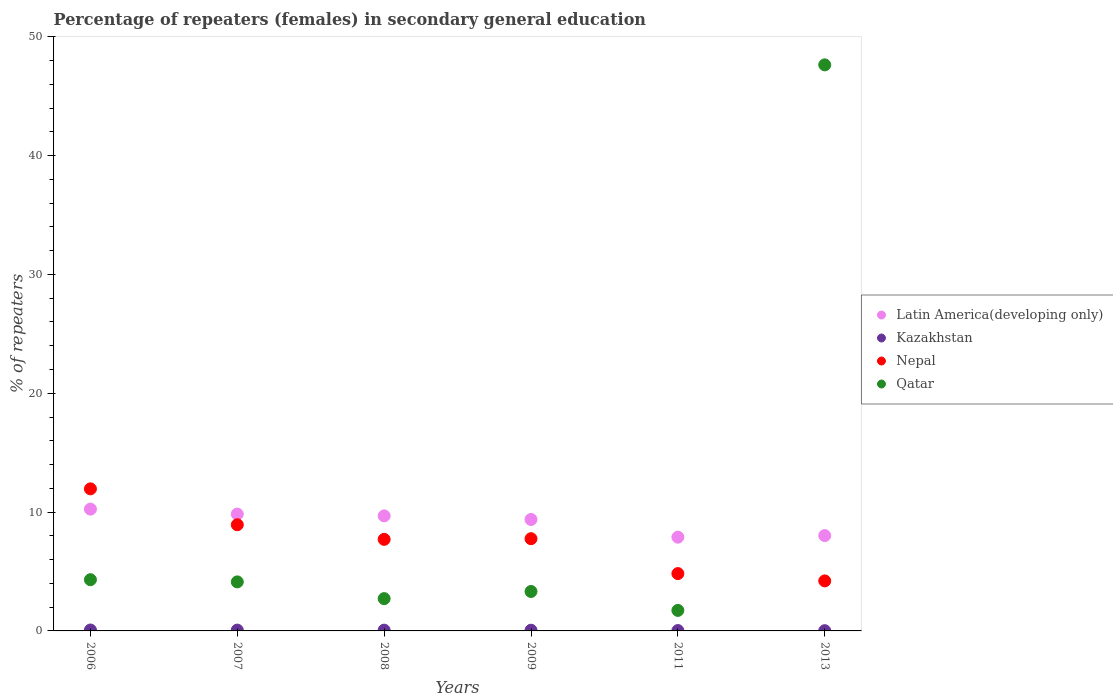Is the number of dotlines equal to the number of legend labels?
Make the answer very short. Yes. What is the percentage of female repeaters in Latin America(developing only) in 2013?
Provide a short and direct response. 8.02. Across all years, what is the maximum percentage of female repeaters in Qatar?
Ensure brevity in your answer.  47.64. Across all years, what is the minimum percentage of female repeaters in Latin America(developing only)?
Your answer should be compact. 7.89. In which year was the percentage of female repeaters in Qatar maximum?
Keep it short and to the point. 2013. What is the total percentage of female repeaters in Latin America(developing only) in the graph?
Make the answer very short. 55.06. What is the difference between the percentage of female repeaters in Latin America(developing only) in 2007 and that in 2013?
Offer a terse response. 1.81. What is the difference between the percentage of female repeaters in Qatar in 2006 and the percentage of female repeaters in Kazakhstan in 2009?
Provide a short and direct response. 4.25. What is the average percentage of female repeaters in Qatar per year?
Offer a very short reply. 10.64. In the year 2013, what is the difference between the percentage of female repeaters in Nepal and percentage of female repeaters in Qatar?
Offer a terse response. -43.43. In how many years, is the percentage of female repeaters in Nepal greater than 22 %?
Your answer should be very brief. 0. What is the ratio of the percentage of female repeaters in Latin America(developing only) in 2006 to that in 2007?
Your answer should be very brief. 1.04. Is the difference between the percentage of female repeaters in Nepal in 2008 and 2009 greater than the difference between the percentage of female repeaters in Qatar in 2008 and 2009?
Your answer should be compact. Yes. What is the difference between the highest and the second highest percentage of female repeaters in Qatar?
Give a very brief answer. 43.33. What is the difference between the highest and the lowest percentage of female repeaters in Latin America(developing only)?
Keep it short and to the point. 2.36. Is the sum of the percentage of female repeaters in Latin America(developing only) in 2008 and 2011 greater than the maximum percentage of female repeaters in Qatar across all years?
Keep it short and to the point. No. Does the percentage of female repeaters in Kazakhstan monotonically increase over the years?
Give a very brief answer. No. Is the percentage of female repeaters in Nepal strictly greater than the percentage of female repeaters in Latin America(developing only) over the years?
Ensure brevity in your answer.  No. Is the percentage of female repeaters in Qatar strictly less than the percentage of female repeaters in Nepal over the years?
Ensure brevity in your answer.  No. Does the graph contain any zero values?
Offer a terse response. No. What is the title of the graph?
Give a very brief answer. Percentage of repeaters (females) in secondary general education. Does "Rwanda" appear as one of the legend labels in the graph?
Keep it short and to the point. No. What is the label or title of the X-axis?
Ensure brevity in your answer.  Years. What is the label or title of the Y-axis?
Provide a succinct answer. % of repeaters. What is the % of repeaters of Latin America(developing only) in 2006?
Your answer should be compact. 10.25. What is the % of repeaters in Kazakhstan in 2006?
Keep it short and to the point. 0.08. What is the % of repeaters in Nepal in 2006?
Offer a terse response. 11.96. What is the % of repeaters in Qatar in 2006?
Ensure brevity in your answer.  4.31. What is the % of repeaters in Latin America(developing only) in 2007?
Your answer should be compact. 9.83. What is the % of repeaters in Kazakhstan in 2007?
Make the answer very short. 0.07. What is the % of repeaters of Nepal in 2007?
Keep it short and to the point. 8.94. What is the % of repeaters in Qatar in 2007?
Ensure brevity in your answer.  4.13. What is the % of repeaters in Latin America(developing only) in 2008?
Offer a very short reply. 9.68. What is the % of repeaters of Kazakhstan in 2008?
Offer a terse response. 0.07. What is the % of repeaters in Nepal in 2008?
Your answer should be compact. 7.71. What is the % of repeaters of Qatar in 2008?
Give a very brief answer. 2.72. What is the % of repeaters of Latin America(developing only) in 2009?
Keep it short and to the point. 9.38. What is the % of repeaters of Kazakhstan in 2009?
Make the answer very short. 0.06. What is the % of repeaters of Nepal in 2009?
Your answer should be very brief. 7.76. What is the % of repeaters of Qatar in 2009?
Your response must be concise. 3.32. What is the % of repeaters of Latin America(developing only) in 2011?
Provide a succinct answer. 7.89. What is the % of repeaters of Kazakhstan in 2011?
Your answer should be compact. 0.03. What is the % of repeaters of Nepal in 2011?
Make the answer very short. 4.83. What is the % of repeaters of Qatar in 2011?
Keep it short and to the point. 1.73. What is the % of repeaters in Latin America(developing only) in 2013?
Offer a terse response. 8.02. What is the % of repeaters of Kazakhstan in 2013?
Provide a short and direct response. 0.02. What is the % of repeaters of Nepal in 2013?
Make the answer very short. 4.21. What is the % of repeaters in Qatar in 2013?
Provide a short and direct response. 47.64. Across all years, what is the maximum % of repeaters in Latin America(developing only)?
Provide a short and direct response. 10.25. Across all years, what is the maximum % of repeaters of Kazakhstan?
Your answer should be compact. 0.08. Across all years, what is the maximum % of repeaters in Nepal?
Offer a terse response. 11.96. Across all years, what is the maximum % of repeaters of Qatar?
Your response must be concise. 47.64. Across all years, what is the minimum % of repeaters of Latin America(developing only)?
Provide a short and direct response. 7.89. Across all years, what is the minimum % of repeaters in Kazakhstan?
Make the answer very short. 0.02. Across all years, what is the minimum % of repeaters of Nepal?
Offer a terse response. 4.21. Across all years, what is the minimum % of repeaters in Qatar?
Keep it short and to the point. 1.73. What is the total % of repeaters in Latin America(developing only) in the graph?
Make the answer very short. 55.06. What is the total % of repeaters of Kazakhstan in the graph?
Give a very brief answer. 0.32. What is the total % of repeaters of Nepal in the graph?
Keep it short and to the point. 45.4. What is the total % of repeaters of Qatar in the graph?
Offer a terse response. 63.84. What is the difference between the % of repeaters in Latin America(developing only) in 2006 and that in 2007?
Your answer should be very brief. 0.42. What is the difference between the % of repeaters of Kazakhstan in 2006 and that in 2007?
Your answer should be compact. 0.01. What is the difference between the % of repeaters in Nepal in 2006 and that in 2007?
Your response must be concise. 3.02. What is the difference between the % of repeaters of Qatar in 2006 and that in 2007?
Make the answer very short. 0.18. What is the difference between the % of repeaters of Latin America(developing only) in 2006 and that in 2008?
Your answer should be very brief. 0.57. What is the difference between the % of repeaters of Kazakhstan in 2006 and that in 2008?
Keep it short and to the point. 0.01. What is the difference between the % of repeaters of Nepal in 2006 and that in 2008?
Provide a succinct answer. 4.25. What is the difference between the % of repeaters of Qatar in 2006 and that in 2008?
Make the answer very short. 1.59. What is the difference between the % of repeaters in Latin America(developing only) in 2006 and that in 2009?
Ensure brevity in your answer.  0.87. What is the difference between the % of repeaters in Kazakhstan in 2006 and that in 2009?
Keep it short and to the point. 0.02. What is the difference between the % of repeaters in Nepal in 2006 and that in 2009?
Offer a terse response. 4.2. What is the difference between the % of repeaters of Latin America(developing only) in 2006 and that in 2011?
Ensure brevity in your answer.  2.36. What is the difference between the % of repeaters in Kazakhstan in 2006 and that in 2011?
Keep it short and to the point. 0.05. What is the difference between the % of repeaters in Nepal in 2006 and that in 2011?
Provide a succinct answer. 7.13. What is the difference between the % of repeaters of Qatar in 2006 and that in 2011?
Offer a terse response. 2.58. What is the difference between the % of repeaters of Latin America(developing only) in 2006 and that in 2013?
Give a very brief answer. 2.23. What is the difference between the % of repeaters of Kazakhstan in 2006 and that in 2013?
Give a very brief answer. 0.06. What is the difference between the % of repeaters in Nepal in 2006 and that in 2013?
Give a very brief answer. 7.75. What is the difference between the % of repeaters of Qatar in 2006 and that in 2013?
Offer a very short reply. -43.33. What is the difference between the % of repeaters in Latin America(developing only) in 2007 and that in 2008?
Your answer should be compact. 0.15. What is the difference between the % of repeaters in Kazakhstan in 2007 and that in 2008?
Your response must be concise. 0. What is the difference between the % of repeaters of Nepal in 2007 and that in 2008?
Provide a succinct answer. 1.23. What is the difference between the % of repeaters of Qatar in 2007 and that in 2008?
Provide a short and direct response. 1.41. What is the difference between the % of repeaters in Latin America(developing only) in 2007 and that in 2009?
Offer a terse response. 0.45. What is the difference between the % of repeaters in Kazakhstan in 2007 and that in 2009?
Give a very brief answer. 0.01. What is the difference between the % of repeaters in Nepal in 2007 and that in 2009?
Your response must be concise. 1.17. What is the difference between the % of repeaters of Qatar in 2007 and that in 2009?
Offer a terse response. 0.81. What is the difference between the % of repeaters of Latin America(developing only) in 2007 and that in 2011?
Provide a succinct answer. 1.94. What is the difference between the % of repeaters of Kazakhstan in 2007 and that in 2011?
Make the answer very short. 0.04. What is the difference between the % of repeaters of Nepal in 2007 and that in 2011?
Offer a terse response. 4.11. What is the difference between the % of repeaters in Qatar in 2007 and that in 2011?
Make the answer very short. 2.4. What is the difference between the % of repeaters of Latin America(developing only) in 2007 and that in 2013?
Your answer should be compact. 1.81. What is the difference between the % of repeaters in Kazakhstan in 2007 and that in 2013?
Give a very brief answer. 0.05. What is the difference between the % of repeaters of Nepal in 2007 and that in 2013?
Keep it short and to the point. 4.73. What is the difference between the % of repeaters in Qatar in 2007 and that in 2013?
Your answer should be compact. -43.51. What is the difference between the % of repeaters of Latin America(developing only) in 2008 and that in 2009?
Make the answer very short. 0.3. What is the difference between the % of repeaters of Kazakhstan in 2008 and that in 2009?
Offer a terse response. 0. What is the difference between the % of repeaters in Nepal in 2008 and that in 2009?
Provide a succinct answer. -0.05. What is the difference between the % of repeaters of Qatar in 2008 and that in 2009?
Offer a terse response. -0.6. What is the difference between the % of repeaters of Latin America(developing only) in 2008 and that in 2011?
Provide a succinct answer. 1.79. What is the difference between the % of repeaters of Kazakhstan in 2008 and that in 2011?
Offer a terse response. 0.03. What is the difference between the % of repeaters of Nepal in 2008 and that in 2011?
Ensure brevity in your answer.  2.88. What is the difference between the % of repeaters in Latin America(developing only) in 2008 and that in 2013?
Ensure brevity in your answer.  1.66. What is the difference between the % of repeaters in Kazakhstan in 2008 and that in 2013?
Your answer should be compact. 0.05. What is the difference between the % of repeaters in Nepal in 2008 and that in 2013?
Offer a very short reply. 3.5. What is the difference between the % of repeaters in Qatar in 2008 and that in 2013?
Provide a succinct answer. -44.92. What is the difference between the % of repeaters of Latin America(developing only) in 2009 and that in 2011?
Provide a succinct answer. 1.49. What is the difference between the % of repeaters of Kazakhstan in 2009 and that in 2011?
Give a very brief answer. 0.03. What is the difference between the % of repeaters of Nepal in 2009 and that in 2011?
Provide a short and direct response. 2.94. What is the difference between the % of repeaters in Qatar in 2009 and that in 2011?
Keep it short and to the point. 1.59. What is the difference between the % of repeaters of Latin America(developing only) in 2009 and that in 2013?
Provide a succinct answer. 1.36. What is the difference between the % of repeaters in Kazakhstan in 2009 and that in 2013?
Offer a very short reply. 0.04. What is the difference between the % of repeaters in Nepal in 2009 and that in 2013?
Your answer should be very brief. 3.55. What is the difference between the % of repeaters in Qatar in 2009 and that in 2013?
Your answer should be compact. -44.32. What is the difference between the % of repeaters in Latin America(developing only) in 2011 and that in 2013?
Your answer should be compact. -0.13. What is the difference between the % of repeaters of Kazakhstan in 2011 and that in 2013?
Keep it short and to the point. 0.01. What is the difference between the % of repeaters of Nepal in 2011 and that in 2013?
Offer a very short reply. 0.62. What is the difference between the % of repeaters of Qatar in 2011 and that in 2013?
Give a very brief answer. -45.91. What is the difference between the % of repeaters in Latin America(developing only) in 2006 and the % of repeaters in Kazakhstan in 2007?
Offer a terse response. 10.18. What is the difference between the % of repeaters of Latin America(developing only) in 2006 and the % of repeaters of Nepal in 2007?
Your answer should be very brief. 1.31. What is the difference between the % of repeaters of Latin America(developing only) in 2006 and the % of repeaters of Qatar in 2007?
Provide a short and direct response. 6.12. What is the difference between the % of repeaters in Kazakhstan in 2006 and the % of repeaters in Nepal in 2007?
Make the answer very short. -8.86. What is the difference between the % of repeaters of Kazakhstan in 2006 and the % of repeaters of Qatar in 2007?
Offer a terse response. -4.05. What is the difference between the % of repeaters of Nepal in 2006 and the % of repeaters of Qatar in 2007?
Ensure brevity in your answer.  7.83. What is the difference between the % of repeaters of Latin America(developing only) in 2006 and the % of repeaters of Kazakhstan in 2008?
Give a very brief answer. 10.18. What is the difference between the % of repeaters in Latin America(developing only) in 2006 and the % of repeaters in Nepal in 2008?
Your answer should be very brief. 2.54. What is the difference between the % of repeaters of Latin America(developing only) in 2006 and the % of repeaters of Qatar in 2008?
Give a very brief answer. 7.53. What is the difference between the % of repeaters in Kazakhstan in 2006 and the % of repeaters in Nepal in 2008?
Provide a short and direct response. -7.63. What is the difference between the % of repeaters of Kazakhstan in 2006 and the % of repeaters of Qatar in 2008?
Provide a succinct answer. -2.64. What is the difference between the % of repeaters of Nepal in 2006 and the % of repeaters of Qatar in 2008?
Your answer should be very brief. 9.24. What is the difference between the % of repeaters in Latin America(developing only) in 2006 and the % of repeaters in Kazakhstan in 2009?
Your answer should be very brief. 10.19. What is the difference between the % of repeaters of Latin America(developing only) in 2006 and the % of repeaters of Nepal in 2009?
Provide a succinct answer. 2.49. What is the difference between the % of repeaters of Latin America(developing only) in 2006 and the % of repeaters of Qatar in 2009?
Keep it short and to the point. 6.93. What is the difference between the % of repeaters of Kazakhstan in 2006 and the % of repeaters of Nepal in 2009?
Provide a short and direct response. -7.68. What is the difference between the % of repeaters in Kazakhstan in 2006 and the % of repeaters in Qatar in 2009?
Your answer should be very brief. -3.24. What is the difference between the % of repeaters in Nepal in 2006 and the % of repeaters in Qatar in 2009?
Make the answer very short. 8.64. What is the difference between the % of repeaters in Latin America(developing only) in 2006 and the % of repeaters in Kazakhstan in 2011?
Give a very brief answer. 10.22. What is the difference between the % of repeaters in Latin America(developing only) in 2006 and the % of repeaters in Nepal in 2011?
Your answer should be very brief. 5.42. What is the difference between the % of repeaters of Latin America(developing only) in 2006 and the % of repeaters of Qatar in 2011?
Offer a terse response. 8.52. What is the difference between the % of repeaters in Kazakhstan in 2006 and the % of repeaters in Nepal in 2011?
Ensure brevity in your answer.  -4.75. What is the difference between the % of repeaters of Kazakhstan in 2006 and the % of repeaters of Qatar in 2011?
Provide a succinct answer. -1.65. What is the difference between the % of repeaters of Nepal in 2006 and the % of repeaters of Qatar in 2011?
Provide a short and direct response. 10.23. What is the difference between the % of repeaters in Latin America(developing only) in 2006 and the % of repeaters in Kazakhstan in 2013?
Ensure brevity in your answer.  10.23. What is the difference between the % of repeaters in Latin America(developing only) in 2006 and the % of repeaters in Nepal in 2013?
Provide a short and direct response. 6.04. What is the difference between the % of repeaters in Latin America(developing only) in 2006 and the % of repeaters in Qatar in 2013?
Your answer should be compact. -37.39. What is the difference between the % of repeaters of Kazakhstan in 2006 and the % of repeaters of Nepal in 2013?
Your answer should be compact. -4.13. What is the difference between the % of repeaters in Kazakhstan in 2006 and the % of repeaters in Qatar in 2013?
Provide a short and direct response. -47.56. What is the difference between the % of repeaters of Nepal in 2006 and the % of repeaters of Qatar in 2013?
Provide a short and direct response. -35.68. What is the difference between the % of repeaters of Latin America(developing only) in 2007 and the % of repeaters of Kazakhstan in 2008?
Ensure brevity in your answer.  9.77. What is the difference between the % of repeaters in Latin America(developing only) in 2007 and the % of repeaters in Nepal in 2008?
Ensure brevity in your answer.  2.13. What is the difference between the % of repeaters in Latin America(developing only) in 2007 and the % of repeaters in Qatar in 2008?
Your answer should be compact. 7.11. What is the difference between the % of repeaters in Kazakhstan in 2007 and the % of repeaters in Nepal in 2008?
Offer a very short reply. -7.64. What is the difference between the % of repeaters in Kazakhstan in 2007 and the % of repeaters in Qatar in 2008?
Offer a very short reply. -2.65. What is the difference between the % of repeaters in Nepal in 2007 and the % of repeaters in Qatar in 2008?
Offer a very short reply. 6.22. What is the difference between the % of repeaters of Latin America(developing only) in 2007 and the % of repeaters of Kazakhstan in 2009?
Offer a terse response. 9.77. What is the difference between the % of repeaters in Latin America(developing only) in 2007 and the % of repeaters in Nepal in 2009?
Your answer should be compact. 2.07. What is the difference between the % of repeaters in Latin America(developing only) in 2007 and the % of repeaters in Qatar in 2009?
Ensure brevity in your answer.  6.51. What is the difference between the % of repeaters of Kazakhstan in 2007 and the % of repeaters of Nepal in 2009?
Your answer should be compact. -7.69. What is the difference between the % of repeaters of Kazakhstan in 2007 and the % of repeaters of Qatar in 2009?
Your response must be concise. -3.25. What is the difference between the % of repeaters of Nepal in 2007 and the % of repeaters of Qatar in 2009?
Offer a very short reply. 5.62. What is the difference between the % of repeaters of Latin America(developing only) in 2007 and the % of repeaters of Kazakhstan in 2011?
Your response must be concise. 9.8. What is the difference between the % of repeaters of Latin America(developing only) in 2007 and the % of repeaters of Nepal in 2011?
Provide a succinct answer. 5.01. What is the difference between the % of repeaters in Latin America(developing only) in 2007 and the % of repeaters in Qatar in 2011?
Your answer should be compact. 8.11. What is the difference between the % of repeaters of Kazakhstan in 2007 and the % of repeaters of Nepal in 2011?
Provide a short and direct response. -4.76. What is the difference between the % of repeaters of Kazakhstan in 2007 and the % of repeaters of Qatar in 2011?
Your answer should be very brief. -1.66. What is the difference between the % of repeaters of Nepal in 2007 and the % of repeaters of Qatar in 2011?
Ensure brevity in your answer.  7.21. What is the difference between the % of repeaters of Latin America(developing only) in 2007 and the % of repeaters of Kazakhstan in 2013?
Keep it short and to the point. 9.81. What is the difference between the % of repeaters in Latin America(developing only) in 2007 and the % of repeaters in Nepal in 2013?
Give a very brief answer. 5.62. What is the difference between the % of repeaters in Latin America(developing only) in 2007 and the % of repeaters in Qatar in 2013?
Offer a very short reply. -37.81. What is the difference between the % of repeaters of Kazakhstan in 2007 and the % of repeaters of Nepal in 2013?
Offer a terse response. -4.14. What is the difference between the % of repeaters of Kazakhstan in 2007 and the % of repeaters of Qatar in 2013?
Your answer should be very brief. -47.57. What is the difference between the % of repeaters of Nepal in 2007 and the % of repeaters of Qatar in 2013?
Ensure brevity in your answer.  -38.7. What is the difference between the % of repeaters in Latin America(developing only) in 2008 and the % of repeaters in Kazakhstan in 2009?
Offer a terse response. 9.62. What is the difference between the % of repeaters of Latin America(developing only) in 2008 and the % of repeaters of Nepal in 2009?
Provide a short and direct response. 1.92. What is the difference between the % of repeaters in Latin America(developing only) in 2008 and the % of repeaters in Qatar in 2009?
Offer a terse response. 6.36. What is the difference between the % of repeaters of Kazakhstan in 2008 and the % of repeaters of Nepal in 2009?
Offer a very short reply. -7.7. What is the difference between the % of repeaters of Kazakhstan in 2008 and the % of repeaters of Qatar in 2009?
Give a very brief answer. -3.25. What is the difference between the % of repeaters in Nepal in 2008 and the % of repeaters in Qatar in 2009?
Make the answer very short. 4.39. What is the difference between the % of repeaters of Latin America(developing only) in 2008 and the % of repeaters of Kazakhstan in 2011?
Your answer should be compact. 9.65. What is the difference between the % of repeaters in Latin America(developing only) in 2008 and the % of repeaters in Nepal in 2011?
Give a very brief answer. 4.86. What is the difference between the % of repeaters of Latin America(developing only) in 2008 and the % of repeaters of Qatar in 2011?
Ensure brevity in your answer.  7.95. What is the difference between the % of repeaters in Kazakhstan in 2008 and the % of repeaters in Nepal in 2011?
Your response must be concise. -4.76. What is the difference between the % of repeaters in Kazakhstan in 2008 and the % of repeaters in Qatar in 2011?
Your response must be concise. -1.66. What is the difference between the % of repeaters in Nepal in 2008 and the % of repeaters in Qatar in 2011?
Your answer should be very brief. 5.98. What is the difference between the % of repeaters of Latin America(developing only) in 2008 and the % of repeaters of Kazakhstan in 2013?
Your answer should be very brief. 9.66. What is the difference between the % of repeaters in Latin America(developing only) in 2008 and the % of repeaters in Nepal in 2013?
Offer a very short reply. 5.47. What is the difference between the % of repeaters in Latin America(developing only) in 2008 and the % of repeaters in Qatar in 2013?
Ensure brevity in your answer.  -37.96. What is the difference between the % of repeaters in Kazakhstan in 2008 and the % of repeaters in Nepal in 2013?
Offer a very short reply. -4.14. What is the difference between the % of repeaters in Kazakhstan in 2008 and the % of repeaters in Qatar in 2013?
Provide a short and direct response. -47.57. What is the difference between the % of repeaters of Nepal in 2008 and the % of repeaters of Qatar in 2013?
Provide a short and direct response. -39.93. What is the difference between the % of repeaters of Latin America(developing only) in 2009 and the % of repeaters of Kazakhstan in 2011?
Make the answer very short. 9.35. What is the difference between the % of repeaters in Latin America(developing only) in 2009 and the % of repeaters in Nepal in 2011?
Offer a very short reply. 4.55. What is the difference between the % of repeaters of Latin America(developing only) in 2009 and the % of repeaters of Qatar in 2011?
Give a very brief answer. 7.65. What is the difference between the % of repeaters in Kazakhstan in 2009 and the % of repeaters in Nepal in 2011?
Provide a short and direct response. -4.76. What is the difference between the % of repeaters of Kazakhstan in 2009 and the % of repeaters of Qatar in 2011?
Provide a succinct answer. -1.67. What is the difference between the % of repeaters of Nepal in 2009 and the % of repeaters of Qatar in 2011?
Provide a short and direct response. 6.03. What is the difference between the % of repeaters of Latin America(developing only) in 2009 and the % of repeaters of Kazakhstan in 2013?
Your answer should be compact. 9.36. What is the difference between the % of repeaters in Latin America(developing only) in 2009 and the % of repeaters in Nepal in 2013?
Your answer should be compact. 5.17. What is the difference between the % of repeaters of Latin America(developing only) in 2009 and the % of repeaters of Qatar in 2013?
Offer a terse response. -38.26. What is the difference between the % of repeaters in Kazakhstan in 2009 and the % of repeaters in Nepal in 2013?
Offer a terse response. -4.15. What is the difference between the % of repeaters in Kazakhstan in 2009 and the % of repeaters in Qatar in 2013?
Make the answer very short. -47.58. What is the difference between the % of repeaters in Nepal in 2009 and the % of repeaters in Qatar in 2013?
Ensure brevity in your answer.  -39.88. What is the difference between the % of repeaters in Latin America(developing only) in 2011 and the % of repeaters in Kazakhstan in 2013?
Provide a short and direct response. 7.87. What is the difference between the % of repeaters of Latin America(developing only) in 2011 and the % of repeaters of Nepal in 2013?
Provide a short and direct response. 3.68. What is the difference between the % of repeaters in Latin America(developing only) in 2011 and the % of repeaters in Qatar in 2013?
Your answer should be compact. -39.75. What is the difference between the % of repeaters of Kazakhstan in 2011 and the % of repeaters of Nepal in 2013?
Ensure brevity in your answer.  -4.18. What is the difference between the % of repeaters of Kazakhstan in 2011 and the % of repeaters of Qatar in 2013?
Make the answer very short. -47.61. What is the difference between the % of repeaters of Nepal in 2011 and the % of repeaters of Qatar in 2013?
Ensure brevity in your answer.  -42.81. What is the average % of repeaters of Latin America(developing only) per year?
Provide a succinct answer. 9.18. What is the average % of repeaters in Kazakhstan per year?
Make the answer very short. 0.05. What is the average % of repeaters in Nepal per year?
Make the answer very short. 7.57. What is the average % of repeaters of Qatar per year?
Offer a terse response. 10.64. In the year 2006, what is the difference between the % of repeaters in Latin America(developing only) and % of repeaters in Kazakhstan?
Ensure brevity in your answer.  10.17. In the year 2006, what is the difference between the % of repeaters in Latin America(developing only) and % of repeaters in Nepal?
Your response must be concise. -1.71. In the year 2006, what is the difference between the % of repeaters of Latin America(developing only) and % of repeaters of Qatar?
Give a very brief answer. 5.94. In the year 2006, what is the difference between the % of repeaters in Kazakhstan and % of repeaters in Nepal?
Keep it short and to the point. -11.88. In the year 2006, what is the difference between the % of repeaters of Kazakhstan and % of repeaters of Qatar?
Your response must be concise. -4.23. In the year 2006, what is the difference between the % of repeaters in Nepal and % of repeaters in Qatar?
Your answer should be very brief. 7.65. In the year 2007, what is the difference between the % of repeaters of Latin America(developing only) and % of repeaters of Kazakhstan?
Your answer should be very brief. 9.76. In the year 2007, what is the difference between the % of repeaters in Latin America(developing only) and % of repeaters in Nepal?
Your answer should be very brief. 0.9. In the year 2007, what is the difference between the % of repeaters of Latin America(developing only) and % of repeaters of Qatar?
Your answer should be compact. 5.71. In the year 2007, what is the difference between the % of repeaters of Kazakhstan and % of repeaters of Nepal?
Your answer should be very brief. -8.87. In the year 2007, what is the difference between the % of repeaters in Kazakhstan and % of repeaters in Qatar?
Your answer should be compact. -4.06. In the year 2007, what is the difference between the % of repeaters of Nepal and % of repeaters of Qatar?
Keep it short and to the point. 4.81. In the year 2008, what is the difference between the % of repeaters of Latin America(developing only) and % of repeaters of Kazakhstan?
Ensure brevity in your answer.  9.62. In the year 2008, what is the difference between the % of repeaters of Latin America(developing only) and % of repeaters of Nepal?
Give a very brief answer. 1.97. In the year 2008, what is the difference between the % of repeaters of Latin America(developing only) and % of repeaters of Qatar?
Keep it short and to the point. 6.96. In the year 2008, what is the difference between the % of repeaters of Kazakhstan and % of repeaters of Nepal?
Your answer should be very brief. -7.64. In the year 2008, what is the difference between the % of repeaters in Kazakhstan and % of repeaters in Qatar?
Your answer should be compact. -2.65. In the year 2008, what is the difference between the % of repeaters in Nepal and % of repeaters in Qatar?
Make the answer very short. 4.99. In the year 2009, what is the difference between the % of repeaters in Latin America(developing only) and % of repeaters in Kazakhstan?
Ensure brevity in your answer.  9.32. In the year 2009, what is the difference between the % of repeaters of Latin America(developing only) and % of repeaters of Nepal?
Provide a succinct answer. 1.62. In the year 2009, what is the difference between the % of repeaters of Latin America(developing only) and % of repeaters of Qatar?
Your answer should be very brief. 6.06. In the year 2009, what is the difference between the % of repeaters in Kazakhstan and % of repeaters in Nepal?
Offer a terse response. -7.7. In the year 2009, what is the difference between the % of repeaters in Kazakhstan and % of repeaters in Qatar?
Offer a very short reply. -3.26. In the year 2009, what is the difference between the % of repeaters of Nepal and % of repeaters of Qatar?
Provide a succinct answer. 4.44. In the year 2011, what is the difference between the % of repeaters of Latin America(developing only) and % of repeaters of Kazakhstan?
Offer a terse response. 7.86. In the year 2011, what is the difference between the % of repeaters in Latin America(developing only) and % of repeaters in Nepal?
Provide a succinct answer. 3.06. In the year 2011, what is the difference between the % of repeaters in Latin America(developing only) and % of repeaters in Qatar?
Offer a terse response. 6.16. In the year 2011, what is the difference between the % of repeaters of Kazakhstan and % of repeaters of Nepal?
Provide a short and direct response. -4.79. In the year 2011, what is the difference between the % of repeaters of Kazakhstan and % of repeaters of Qatar?
Keep it short and to the point. -1.7. In the year 2011, what is the difference between the % of repeaters in Nepal and % of repeaters in Qatar?
Your answer should be very brief. 3.1. In the year 2013, what is the difference between the % of repeaters of Latin America(developing only) and % of repeaters of Kazakhstan?
Provide a short and direct response. 8. In the year 2013, what is the difference between the % of repeaters in Latin America(developing only) and % of repeaters in Nepal?
Your response must be concise. 3.81. In the year 2013, what is the difference between the % of repeaters of Latin America(developing only) and % of repeaters of Qatar?
Offer a very short reply. -39.61. In the year 2013, what is the difference between the % of repeaters of Kazakhstan and % of repeaters of Nepal?
Your answer should be very brief. -4.19. In the year 2013, what is the difference between the % of repeaters of Kazakhstan and % of repeaters of Qatar?
Offer a terse response. -47.62. In the year 2013, what is the difference between the % of repeaters of Nepal and % of repeaters of Qatar?
Your answer should be very brief. -43.43. What is the ratio of the % of repeaters of Latin America(developing only) in 2006 to that in 2007?
Provide a short and direct response. 1.04. What is the ratio of the % of repeaters of Kazakhstan in 2006 to that in 2007?
Ensure brevity in your answer.  1.1. What is the ratio of the % of repeaters of Nepal in 2006 to that in 2007?
Your answer should be very brief. 1.34. What is the ratio of the % of repeaters of Qatar in 2006 to that in 2007?
Give a very brief answer. 1.04. What is the ratio of the % of repeaters of Latin America(developing only) in 2006 to that in 2008?
Your answer should be very brief. 1.06. What is the ratio of the % of repeaters in Kazakhstan in 2006 to that in 2008?
Your response must be concise. 1.17. What is the ratio of the % of repeaters of Nepal in 2006 to that in 2008?
Offer a terse response. 1.55. What is the ratio of the % of repeaters in Qatar in 2006 to that in 2008?
Give a very brief answer. 1.59. What is the ratio of the % of repeaters in Latin America(developing only) in 2006 to that in 2009?
Provide a succinct answer. 1.09. What is the ratio of the % of repeaters in Kazakhstan in 2006 to that in 2009?
Provide a short and direct response. 1.26. What is the ratio of the % of repeaters of Nepal in 2006 to that in 2009?
Offer a very short reply. 1.54. What is the ratio of the % of repeaters of Qatar in 2006 to that in 2009?
Offer a terse response. 1.3. What is the ratio of the % of repeaters in Latin America(developing only) in 2006 to that in 2011?
Provide a short and direct response. 1.3. What is the ratio of the % of repeaters of Kazakhstan in 2006 to that in 2011?
Your response must be concise. 2.49. What is the ratio of the % of repeaters in Nepal in 2006 to that in 2011?
Your answer should be very brief. 2.48. What is the ratio of the % of repeaters of Qatar in 2006 to that in 2011?
Make the answer very short. 2.5. What is the ratio of the % of repeaters in Latin America(developing only) in 2006 to that in 2013?
Offer a terse response. 1.28. What is the ratio of the % of repeaters of Kazakhstan in 2006 to that in 2013?
Your answer should be compact. 3.89. What is the ratio of the % of repeaters of Nepal in 2006 to that in 2013?
Give a very brief answer. 2.84. What is the ratio of the % of repeaters in Qatar in 2006 to that in 2013?
Provide a short and direct response. 0.09. What is the ratio of the % of repeaters in Latin America(developing only) in 2007 to that in 2008?
Your answer should be very brief. 1.02. What is the ratio of the % of repeaters of Kazakhstan in 2007 to that in 2008?
Your answer should be compact. 1.06. What is the ratio of the % of repeaters of Nepal in 2007 to that in 2008?
Offer a very short reply. 1.16. What is the ratio of the % of repeaters of Qatar in 2007 to that in 2008?
Offer a very short reply. 1.52. What is the ratio of the % of repeaters of Latin America(developing only) in 2007 to that in 2009?
Provide a succinct answer. 1.05. What is the ratio of the % of repeaters of Kazakhstan in 2007 to that in 2009?
Your answer should be very brief. 1.15. What is the ratio of the % of repeaters in Nepal in 2007 to that in 2009?
Ensure brevity in your answer.  1.15. What is the ratio of the % of repeaters in Qatar in 2007 to that in 2009?
Your response must be concise. 1.24. What is the ratio of the % of repeaters of Latin America(developing only) in 2007 to that in 2011?
Your answer should be compact. 1.25. What is the ratio of the % of repeaters in Kazakhstan in 2007 to that in 2011?
Provide a succinct answer. 2.26. What is the ratio of the % of repeaters in Nepal in 2007 to that in 2011?
Provide a short and direct response. 1.85. What is the ratio of the % of repeaters of Qatar in 2007 to that in 2011?
Offer a terse response. 2.39. What is the ratio of the % of repeaters of Latin America(developing only) in 2007 to that in 2013?
Make the answer very short. 1.23. What is the ratio of the % of repeaters in Kazakhstan in 2007 to that in 2013?
Offer a very short reply. 3.52. What is the ratio of the % of repeaters of Nepal in 2007 to that in 2013?
Your response must be concise. 2.12. What is the ratio of the % of repeaters in Qatar in 2007 to that in 2013?
Ensure brevity in your answer.  0.09. What is the ratio of the % of repeaters in Latin America(developing only) in 2008 to that in 2009?
Your answer should be compact. 1.03. What is the ratio of the % of repeaters of Kazakhstan in 2008 to that in 2009?
Offer a terse response. 1.08. What is the ratio of the % of repeaters of Nepal in 2008 to that in 2009?
Offer a very short reply. 0.99. What is the ratio of the % of repeaters of Qatar in 2008 to that in 2009?
Your answer should be very brief. 0.82. What is the ratio of the % of repeaters in Latin America(developing only) in 2008 to that in 2011?
Keep it short and to the point. 1.23. What is the ratio of the % of repeaters in Kazakhstan in 2008 to that in 2011?
Your answer should be very brief. 2.13. What is the ratio of the % of repeaters of Nepal in 2008 to that in 2011?
Provide a succinct answer. 1.6. What is the ratio of the % of repeaters of Qatar in 2008 to that in 2011?
Give a very brief answer. 1.57. What is the ratio of the % of repeaters of Latin America(developing only) in 2008 to that in 2013?
Keep it short and to the point. 1.21. What is the ratio of the % of repeaters of Kazakhstan in 2008 to that in 2013?
Provide a succinct answer. 3.31. What is the ratio of the % of repeaters in Nepal in 2008 to that in 2013?
Provide a succinct answer. 1.83. What is the ratio of the % of repeaters of Qatar in 2008 to that in 2013?
Offer a terse response. 0.06. What is the ratio of the % of repeaters of Latin America(developing only) in 2009 to that in 2011?
Your answer should be compact. 1.19. What is the ratio of the % of repeaters in Kazakhstan in 2009 to that in 2011?
Provide a succinct answer. 1.97. What is the ratio of the % of repeaters of Nepal in 2009 to that in 2011?
Offer a very short reply. 1.61. What is the ratio of the % of repeaters in Qatar in 2009 to that in 2011?
Your answer should be compact. 1.92. What is the ratio of the % of repeaters in Latin America(developing only) in 2009 to that in 2013?
Provide a succinct answer. 1.17. What is the ratio of the % of repeaters in Kazakhstan in 2009 to that in 2013?
Ensure brevity in your answer.  3.07. What is the ratio of the % of repeaters of Nepal in 2009 to that in 2013?
Your answer should be compact. 1.84. What is the ratio of the % of repeaters in Qatar in 2009 to that in 2013?
Ensure brevity in your answer.  0.07. What is the ratio of the % of repeaters in Latin America(developing only) in 2011 to that in 2013?
Keep it short and to the point. 0.98. What is the ratio of the % of repeaters of Kazakhstan in 2011 to that in 2013?
Keep it short and to the point. 1.56. What is the ratio of the % of repeaters of Nepal in 2011 to that in 2013?
Your answer should be compact. 1.15. What is the ratio of the % of repeaters in Qatar in 2011 to that in 2013?
Your answer should be very brief. 0.04. What is the difference between the highest and the second highest % of repeaters in Latin America(developing only)?
Ensure brevity in your answer.  0.42. What is the difference between the highest and the second highest % of repeaters in Kazakhstan?
Your answer should be compact. 0.01. What is the difference between the highest and the second highest % of repeaters of Nepal?
Your answer should be very brief. 3.02. What is the difference between the highest and the second highest % of repeaters of Qatar?
Provide a short and direct response. 43.33. What is the difference between the highest and the lowest % of repeaters of Latin America(developing only)?
Your answer should be compact. 2.36. What is the difference between the highest and the lowest % of repeaters in Kazakhstan?
Ensure brevity in your answer.  0.06. What is the difference between the highest and the lowest % of repeaters of Nepal?
Offer a terse response. 7.75. What is the difference between the highest and the lowest % of repeaters in Qatar?
Provide a succinct answer. 45.91. 